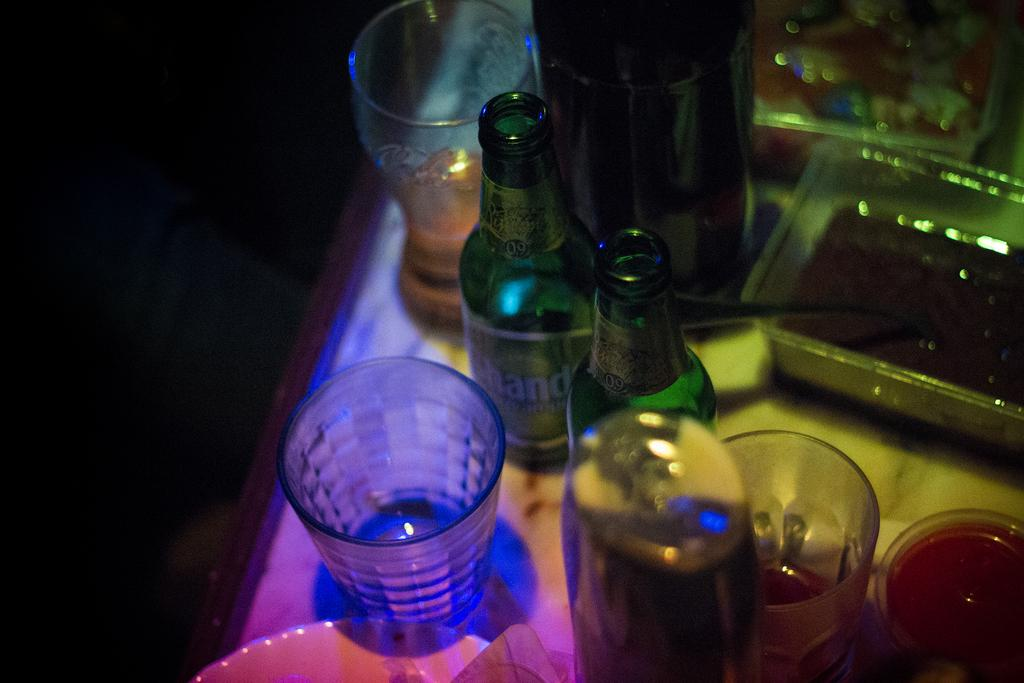<image>
Create a compact narrative representing the image presented. A lit up bar with a bottle of 4 hands beer on it 